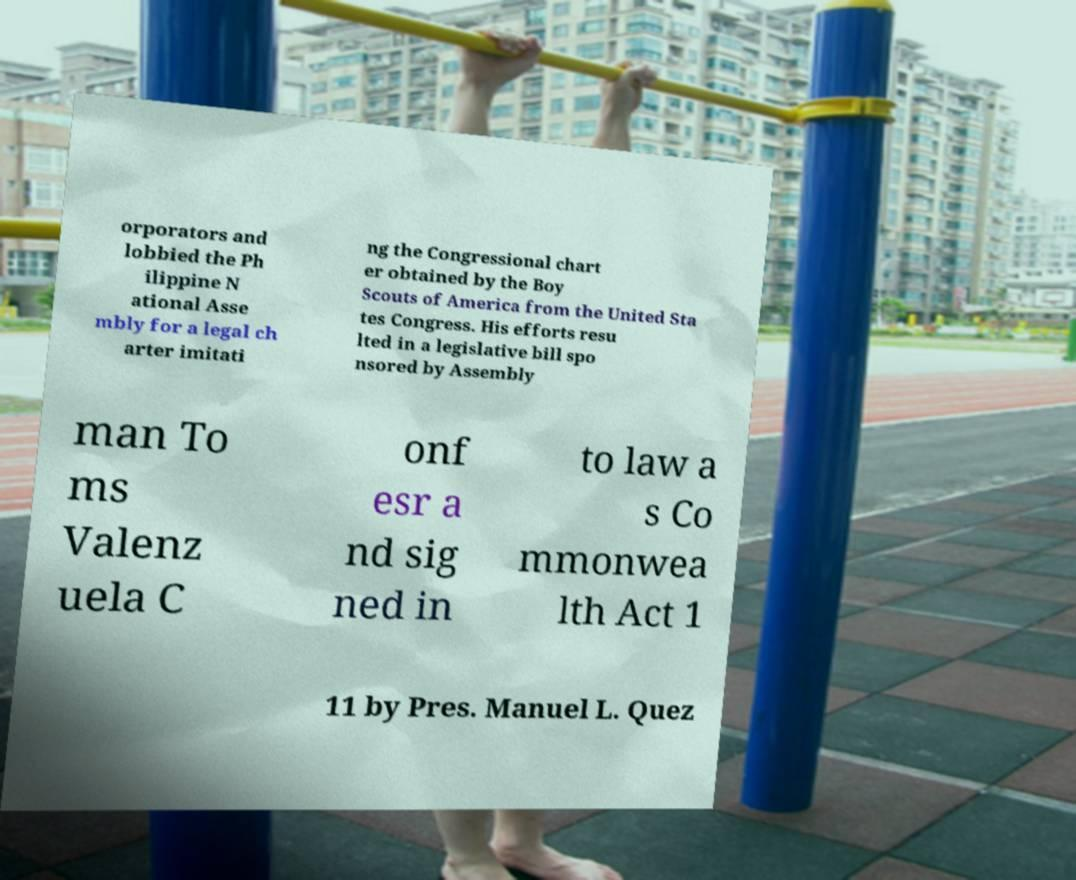There's text embedded in this image that I need extracted. Can you transcribe it verbatim? orporators and lobbied the Ph ilippine N ational Asse mbly for a legal ch arter imitati ng the Congressional chart er obtained by the Boy Scouts of America from the United Sta tes Congress. His efforts resu lted in a legislative bill spo nsored by Assembly man To ms Valenz uela C onf esr a nd sig ned in to law a s Co mmonwea lth Act 1 11 by Pres. Manuel L. Quez 